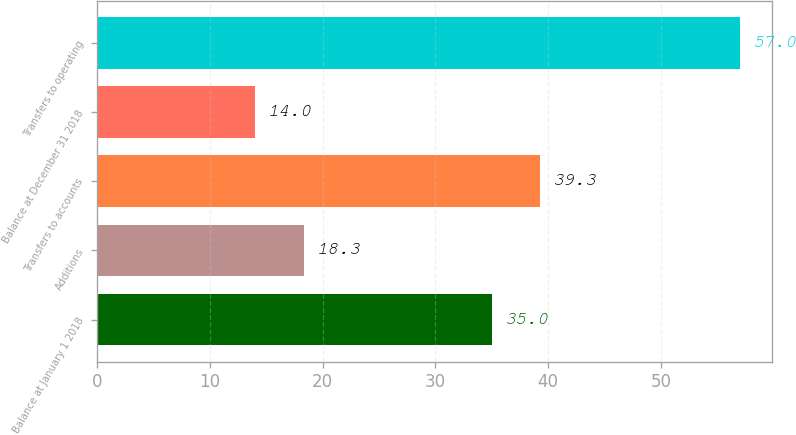<chart> <loc_0><loc_0><loc_500><loc_500><bar_chart><fcel>Balance at January 1 2018<fcel>Additions<fcel>Transfers to accounts<fcel>Balance at December 31 2018<fcel>Transfers to operating<nl><fcel>35<fcel>18.3<fcel>39.3<fcel>14<fcel>57<nl></chart> 